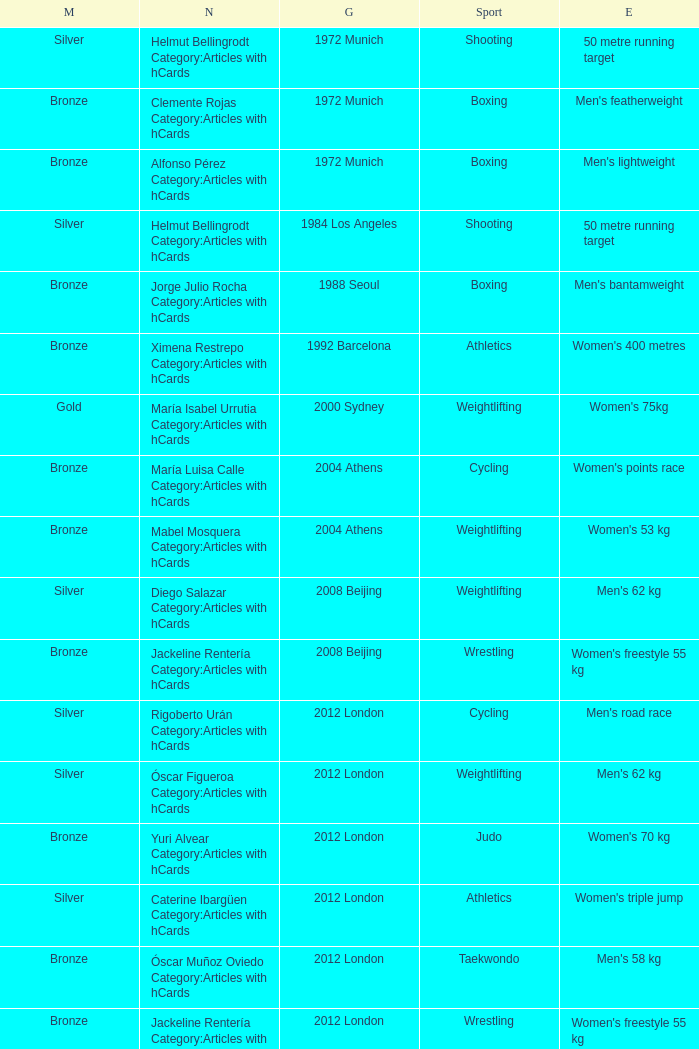Which sport resulted in a gold medal in the 2000 Sydney games? Weightlifting. 